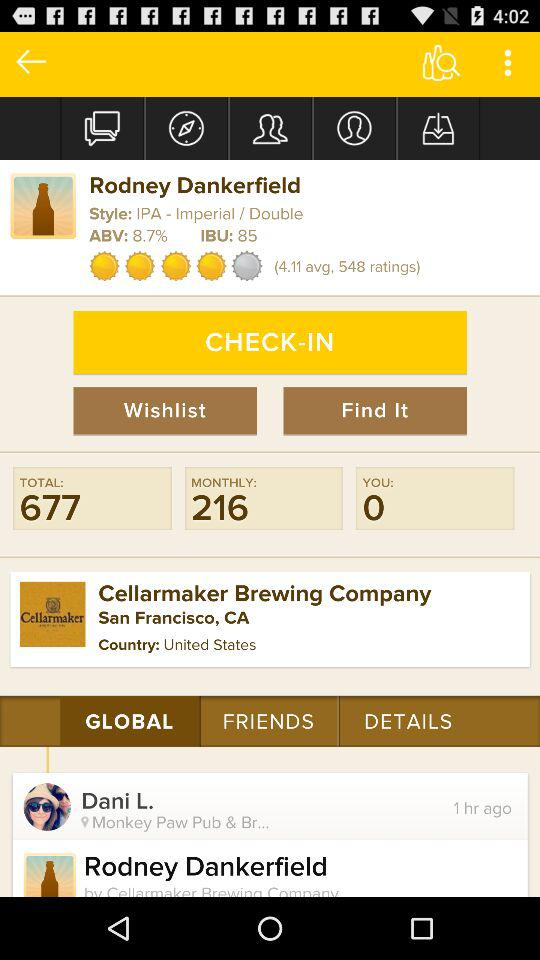What's the style of Rodney Dankerfield? The style is "IPA - Imperial / Double". 